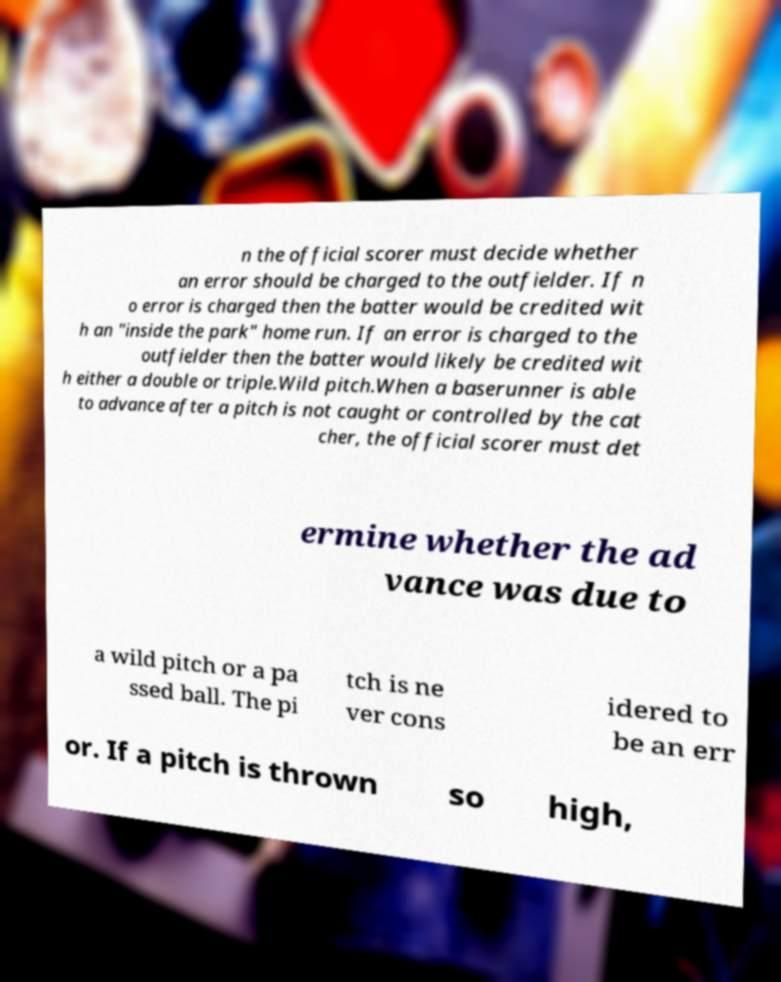Can you read and provide the text displayed in the image?This photo seems to have some interesting text. Can you extract and type it out for me? n the official scorer must decide whether an error should be charged to the outfielder. If n o error is charged then the batter would be credited wit h an "inside the park" home run. If an error is charged to the outfielder then the batter would likely be credited wit h either a double or triple.Wild pitch.When a baserunner is able to advance after a pitch is not caught or controlled by the cat cher, the official scorer must det ermine whether the ad vance was due to a wild pitch or a pa ssed ball. The pi tch is ne ver cons idered to be an err or. If a pitch is thrown so high, 